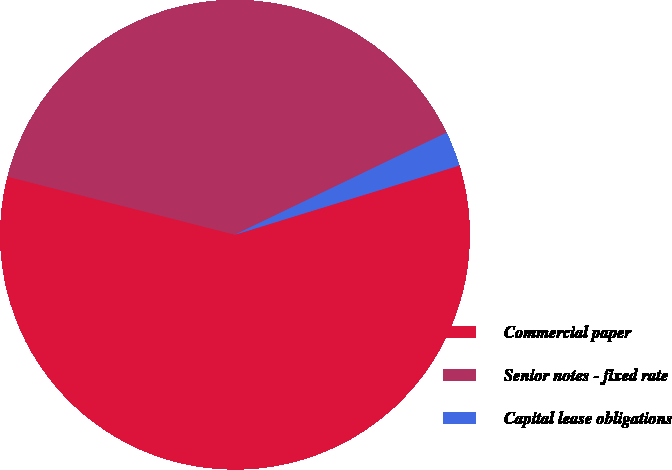<chart> <loc_0><loc_0><loc_500><loc_500><pie_chart><fcel>Commercial paper<fcel>Senior notes - fixed rate<fcel>Capital lease obligations<nl><fcel>58.74%<fcel>38.87%<fcel>2.39%<nl></chart> 